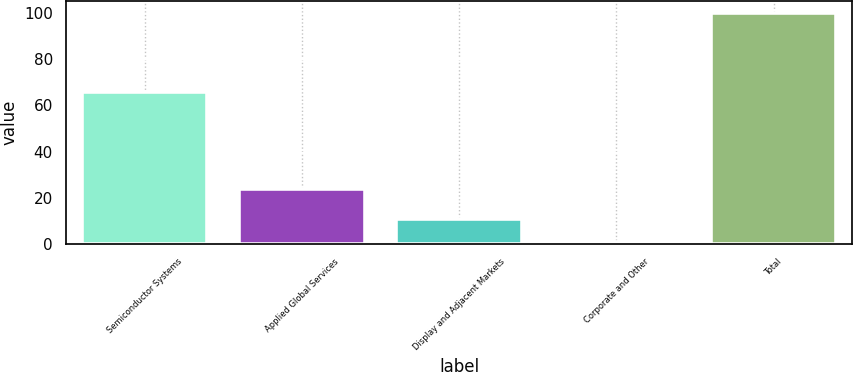Convert chart. <chart><loc_0><loc_0><loc_500><loc_500><bar_chart><fcel>Semiconductor Systems<fcel>Applied Global Services<fcel>Display and Adjacent Markets<fcel>Corporate and Other<fcel>Total<nl><fcel>66<fcel>24<fcel>10.9<fcel>1<fcel>100<nl></chart> 